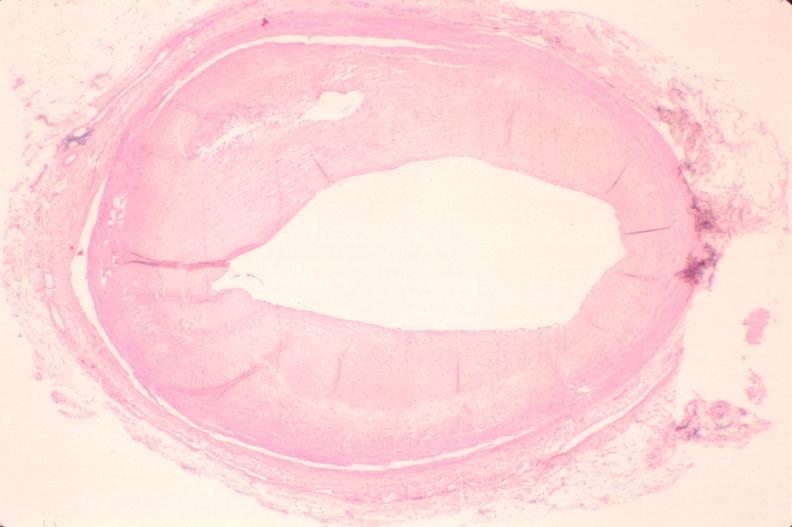what left anterior descending coronary artery?
Answer the question using a single word or phrase. Atherosclerosis 